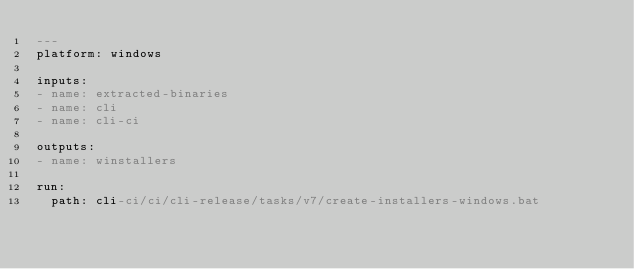<code> <loc_0><loc_0><loc_500><loc_500><_YAML_>---
platform: windows

inputs:
- name: extracted-binaries
- name: cli
- name: cli-ci

outputs:
- name: winstallers

run:
  path: cli-ci/ci/cli-release/tasks/v7/create-installers-windows.bat
</code> 